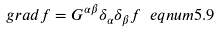Convert formula to latex. <formula><loc_0><loc_0><loc_500><loc_500>g r a d f = G ^ { \alpha \beta } \delta _ { \alpha } \delta _ { \beta } f \ e q n u m { 5 . 9 }</formula> 